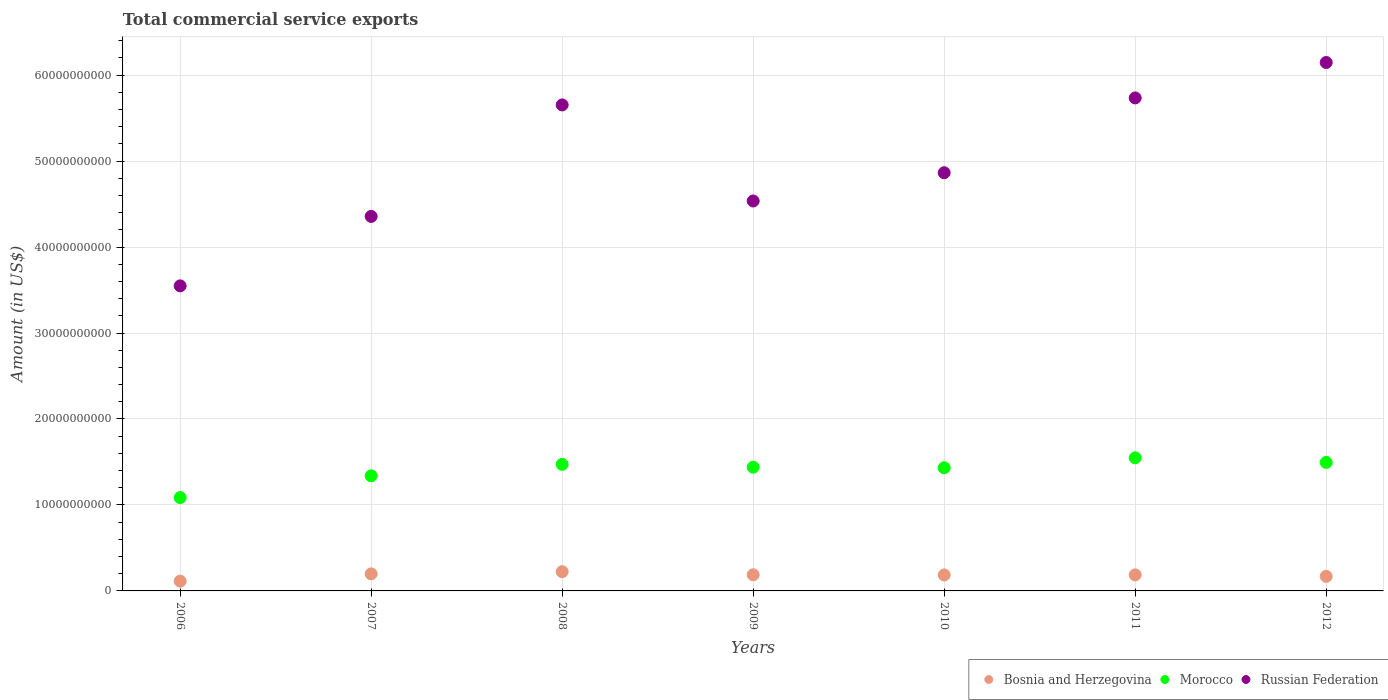How many different coloured dotlines are there?
Offer a very short reply. 3. What is the total commercial service exports in Russian Federation in 2009?
Your response must be concise. 4.54e+1. Across all years, what is the maximum total commercial service exports in Morocco?
Provide a short and direct response. 1.55e+1. Across all years, what is the minimum total commercial service exports in Morocco?
Make the answer very short. 1.09e+1. In which year was the total commercial service exports in Morocco minimum?
Your answer should be very brief. 2006. What is the total total commercial service exports in Morocco in the graph?
Make the answer very short. 9.81e+1. What is the difference between the total commercial service exports in Bosnia and Herzegovina in 2011 and that in 2012?
Make the answer very short. 1.73e+08. What is the difference between the total commercial service exports in Russian Federation in 2010 and the total commercial service exports in Bosnia and Herzegovina in 2009?
Give a very brief answer. 4.68e+1. What is the average total commercial service exports in Bosnia and Herzegovina per year?
Make the answer very short. 1.81e+09. In the year 2009, what is the difference between the total commercial service exports in Morocco and total commercial service exports in Bosnia and Herzegovina?
Ensure brevity in your answer.  1.25e+1. What is the ratio of the total commercial service exports in Russian Federation in 2006 to that in 2007?
Make the answer very short. 0.81. Is the total commercial service exports in Morocco in 2006 less than that in 2009?
Your answer should be very brief. Yes. Is the difference between the total commercial service exports in Morocco in 2006 and 2008 greater than the difference between the total commercial service exports in Bosnia and Herzegovina in 2006 and 2008?
Offer a very short reply. No. What is the difference between the highest and the second highest total commercial service exports in Russian Federation?
Give a very brief answer. 4.12e+09. What is the difference between the highest and the lowest total commercial service exports in Russian Federation?
Offer a terse response. 2.60e+1. In how many years, is the total commercial service exports in Morocco greater than the average total commercial service exports in Morocco taken over all years?
Your answer should be very brief. 5. Does the total commercial service exports in Russian Federation monotonically increase over the years?
Ensure brevity in your answer.  No. Is the total commercial service exports in Morocco strictly greater than the total commercial service exports in Russian Federation over the years?
Keep it short and to the point. No. Is the total commercial service exports in Bosnia and Herzegovina strictly less than the total commercial service exports in Russian Federation over the years?
Make the answer very short. Yes. How many years are there in the graph?
Make the answer very short. 7. What is the difference between two consecutive major ticks on the Y-axis?
Your response must be concise. 1.00e+1. Are the values on the major ticks of Y-axis written in scientific E-notation?
Your answer should be compact. No. Does the graph contain grids?
Your response must be concise. Yes. How are the legend labels stacked?
Your response must be concise. Horizontal. What is the title of the graph?
Your answer should be very brief. Total commercial service exports. What is the label or title of the Y-axis?
Keep it short and to the point. Amount (in US$). What is the Amount (in US$) of Bosnia and Herzegovina in 2006?
Provide a succinct answer. 1.14e+09. What is the Amount (in US$) in Morocco in 2006?
Give a very brief answer. 1.09e+1. What is the Amount (in US$) in Russian Federation in 2006?
Keep it short and to the point. 3.55e+1. What is the Amount (in US$) of Bosnia and Herzegovina in 2007?
Ensure brevity in your answer.  1.99e+09. What is the Amount (in US$) in Morocco in 2007?
Provide a succinct answer. 1.34e+1. What is the Amount (in US$) in Russian Federation in 2007?
Your answer should be compact. 4.36e+1. What is the Amount (in US$) in Bosnia and Herzegovina in 2008?
Provide a succinct answer. 2.24e+09. What is the Amount (in US$) in Morocco in 2008?
Provide a succinct answer. 1.47e+1. What is the Amount (in US$) of Russian Federation in 2008?
Your answer should be compact. 5.65e+1. What is the Amount (in US$) of Bosnia and Herzegovina in 2009?
Provide a succinct answer. 1.88e+09. What is the Amount (in US$) of Morocco in 2009?
Make the answer very short. 1.44e+1. What is the Amount (in US$) in Russian Federation in 2009?
Keep it short and to the point. 4.54e+1. What is the Amount (in US$) in Bosnia and Herzegovina in 2010?
Keep it short and to the point. 1.86e+09. What is the Amount (in US$) of Morocco in 2010?
Give a very brief answer. 1.43e+1. What is the Amount (in US$) of Russian Federation in 2010?
Provide a short and direct response. 4.86e+1. What is the Amount (in US$) in Bosnia and Herzegovina in 2011?
Your answer should be very brief. 1.87e+09. What is the Amount (in US$) in Morocco in 2011?
Make the answer very short. 1.55e+1. What is the Amount (in US$) in Russian Federation in 2011?
Make the answer very short. 5.73e+1. What is the Amount (in US$) in Bosnia and Herzegovina in 2012?
Offer a terse response. 1.69e+09. What is the Amount (in US$) in Morocco in 2012?
Your answer should be very brief. 1.49e+1. What is the Amount (in US$) in Russian Federation in 2012?
Keep it short and to the point. 6.15e+1. Across all years, what is the maximum Amount (in US$) in Bosnia and Herzegovina?
Give a very brief answer. 2.24e+09. Across all years, what is the maximum Amount (in US$) of Morocco?
Your response must be concise. 1.55e+1. Across all years, what is the maximum Amount (in US$) in Russian Federation?
Provide a short and direct response. 6.15e+1. Across all years, what is the minimum Amount (in US$) in Bosnia and Herzegovina?
Ensure brevity in your answer.  1.14e+09. Across all years, what is the minimum Amount (in US$) in Morocco?
Offer a very short reply. 1.09e+1. Across all years, what is the minimum Amount (in US$) in Russian Federation?
Make the answer very short. 3.55e+1. What is the total Amount (in US$) in Bosnia and Herzegovina in the graph?
Offer a very short reply. 1.27e+1. What is the total Amount (in US$) in Morocco in the graph?
Give a very brief answer. 9.81e+1. What is the total Amount (in US$) of Russian Federation in the graph?
Keep it short and to the point. 3.48e+11. What is the difference between the Amount (in US$) in Bosnia and Herzegovina in 2006 and that in 2007?
Make the answer very short. -8.48e+08. What is the difference between the Amount (in US$) of Morocco in 2006 and that in 2007?
Your answer should be compact. -2.53e+09. What is the difference between the Amount (in US$) of Russian Federation in 2006 and that in 2007?
Give a very brief answer. -8.08e+09. What is the difference between the Amount (in US$) of Bosnia and Herzegovina in 2006 and that in 2008?
Provide a succinct answer. -1.10e+09. What is the difference between the Amount (in US$) in Morocco in 2006 and that in 2008?
Provide a succinct answer. -3.87e+09. What is the difference between the Amount (in US$) of Russian Federation in 2006 and that in 2008?
Your answer should be compact. -2.10e+1. What is the difference between the Amount (in US$) of Bosnia and Herzegovina in 2006 and that in 2009?
Offer a terse response. -7.43e+08. What is the difference between the Amount (in US$) of Morocco in 2006 and that in 2009?
Ensure brevity in your answer.  -3.53e+09. What is the difference between the Amount (in US$) of Russian Federation in 2006 and that in 2009?
Provide a short and direct response. -9.87e+09. What is the difference between the Amount (in US$) of Bosnia and Herzegovina in 2006 and that in 2010?
Offer a terse response. -7.23e+08. What is the difference between the Amount (in US$) of Morocco in 2006 and that in 2010?
Your response must be concise. -3.47e+09. What is the difference between the Amount (in US$) in Russian Federation in 2006 and that in 2010?
Provide a short and direct response. -1.32e+1. What is the difference between the Amount (in US$) of Bosnia and Herzegovina in 2006 and that in 2011?
Offer a terse response. -7.30e+08. What is the difference between the Amount (in US$) of Morocco in 2006 and that in 2011?
Provide a succinct answer. -4.63e+09. What is the difference between the Amount (in US$) in Russian Federation in 2006 and that in 2011?
Keep it short and to the point. -2.19e+1. What is the difference between the Amount (in US$) in Bosnia and Herzegovina in 2006 and that in 2012?
Your answer should be compact. -5.57e+08. What is the difference between the Amount (in US$) of Morocco in 2006 and that in 2012?
Offer a very short reply. -4.09e+09. What is the difference between the Amount (in US$) of Russian Federation in 2006 and that in 2012?
Your response must be concise. -2.60e+1. What is the difference between the Amount (in US$) of Bosnia and Herzegovina in 2007 and that in 2008?
Give a very brief answer. -2.53e+08. What is the difference between the Amount (in US$) of Morocco in 2007 and that in 2008?
Your answer should be very brief. -1.34e+09. What is the difference between the Amount (in US$) in Russian Federation in 2007 and that in 2008?
Provide a succinct answer. -1.30e+1. What is the difference between the Amount (in US$) of Bosnia and Herzegovina in 2007 and that in 2009?
Ensure brevity in your answer.  1.05e+08. What is the difference between the Amount (in US$) of Morocco in 2007 and that in 2009?
Provide a short and direct response. -9.99e+08. What is the difference between the Amount (in US$) of Russian Federation in 2007 and that in 2009?
Your answer should be compact. -1.79e+09. What is the difference between the Amount (in US$) in Bosnia and Herzegovina in 2007 and that in 2010?
Offer a terse response. 1.25e+08. What is the difference between the Amount (in US$) of Morocco in 2007 and that in 2010?
Give a very brief answer. -9.39e+08. What is the difference between the Amount (in US$) of Russian Federation in 2007 and that in 2010?
Provide a short and direct response. -5.08e+09. What is the difference between the Amount (in US$) in Bosnia and Herzegovina in 2007 and that in 2011?
Your answer should be compact. 1.18e+08. What is the difference between the Amount (in US$) of Morocco in 2007 and that in 2011?
Provide a succinct answer. -2.10e+09. What is the difference between the Amount (in US$) of Russian Federation in 2007 and that in 2011?
Offer a very short reply. -1.38e+1. What is the difference between the Amount (in US$) of Bosnia and Herzegovina in 2007 and that in 2012?
Your answer should be very brief. 2.91e+08. What is the difference between the Amount (in US$) of Morocco in 2007 and that in 2012?
Your response must be concise. -1.56e+09. What is the difference between the Amount (in US$) of Russian Federation in 2007 and that in 2012?
Your response must be concise. -1.79e+1. What is the difference between the Amount (in US$) in Bosnia and Herzegovina in 2008 and that in 2009?
Offer a very short reply. 3.57e+08. What is the difference between the Amount (in US$) of Morocco in 2008 and that in 2009?
Your answer should be compact. 3.37e+08. What is the difference between the Amount (in US$) in Russian Federation in 2008 and that in 2009?
Offer a very short reply. 1.12e+1. What is the difference between the Amount (in US$) of Bosnia and Herzegovina in 2008 and that in 2010?
Offer a terse response. 3.77e+08. What is the difference between the Amount (in US$) in Morocco in 2008 and that in 2010?
Offer a terse response. 3.96e+08. What is the difference between the Amount (in US$) of Russian Federation in 2008 and that in 2010?
Your answer should be compact. 7.89e+09. What is the difference between the Amount (in US$) of Bosnia and Herzegovina in 2008 and that in 2011?
Keep it short and to the point. 3.70e+08. What is the difference between the Amount (in US$) of Morocco in 2008 and that in 2011?
Keep it short and to the point. -7.61e+08. What is the difference between the Amount (in US$) in Russian Federation in 2008 and that in 2011?
Your answer should be very brief. -8.14e+08. What is the difference between the Amount (in US$) of Bosnia and Herzegovina in 2008 and that in 2012?
Offer a terse response. 5.44e+08. What is the difference between the Amount (in US$) of Morocco in 2008 and that in 2012?
Provide a short and direct response. -2.22e+08. What is the difference between the Amount (in US$) of Russian Federation in 2008 and that in 2012?
Offer a terse response. -4.93e+09. What is the difference between the Amount (in US$) in Bosnia and Herzegovina in 2009 and that in 2010?
Keep it short and to the point. 2.00e+07. What is the difference between the Amount (in US$) of Morocco in 2009 and that in 2010?
Your answer should be compact. 5.92e+07. What is the difference between the Amount (in US$) of Russian Federation in 2009 and that in 2010?
Your answer should be very brief. -3.29e+09. What is the difference between the Amount (in US$) of Bosnia and Herzegovina in 2009 and that in 2011?
Provide a succinct answer. 1.30e+07. What is the difference between the Amount (in US$) in Morocco in 2009 and that in 2011?
Provide a succinct answer. -1.10e+09. What is the difference between the Amount (in US$) of Russian Federation in 2009 and that in 2011?
Offer a very short reply. -1.20e+1. What is the difference between the Amount (in US$) in Bosnia and Herzegovina in 2009 and that in 2012?
Offer a terse response. 1.86e+08. What is the difference between the Amount (in US$) in Morocco in 2009 and that in 2012?
Offer a terse response. -5.58e+08. What is the difference between the Amount (in US$) in Russian Federation in 2009 and that in 2012?
Your response must be concise. -1.61e+1. What is the difference between the Amount (in US$) of Bosnia and Herzegovina in 2010 and that in 2011?
Your answer should be very brief. -7.01e+06. What is the difference between the Amount (in US$) of Morocco in 2010 and that in 2011?
Offer a terse response. -1.16e+09. What is the difference between the Amount (in US$) of Russian Federation in 2010 and that in 2011?
Your response must be concise. -8.70e+09. What is the difference between the Amount (in US$) in Bosnia and Herzegovina in 2010 and that in 2012?
Provide a short and direct response. 1.66e+08. What is the difference between the Amount (in US$) of Morocco in 2010 and that in 2012?
Your response must be concise. -6.18e+08. What is the difference between the Amount (in US$) in Russian Federation in 2010 and that in 2012?
Give a very brief answer. -1.28e+1. What is the difference between the Amount (in US$) in Bosnia and Herzegovina in 2011 and that in 2012?
Provide a short and direct response. 1.73e+08. What is the difference between the Amount (in US$) of Morocco in 2011 and that in 2012?
Provide a succinct answer. 5.40e+08. What is the difference between the Amount (in US$) in Russian Federation in 2011 and that in 2012?
Make the answer very short. -4.12e+09. What is the difference between the Amount (in US$) of Bosnia and Herzegovina in 2006 and the Amount (in US$) of Morocco in 2007?
Provide a short and direct response. -1.23e+1. What is the difference between the Amount (in US$) of Bosnia and Herzegovina in 2006 and the Amount (in US$) of Russian Federation in 2007?
Provide a short and direct response. -4.24e+1. What is the difference between the Amount (in US$) of Morocco in 2006 and the Amount (in US$) of Russian Federation in 2007?
Give a very brief answer. -3.27e+1. What is the difference between the Amount (in US$) in Bosnia and Herzegovina in 2006 and the Amount (in US$) in Morocco in 2008?
Your answer should be very brief. -1.36e+1. What is the difference between the Amount (in US$) of Bosnia and Herzegovina in 2006 and the Amount (in US$) of Russian Federation in 2008?
Provide a succinct answer. -5.54e+1. What is the difference between the Amount (in US$) in Morocco in 2006 and the Amount (in US$) in Russian Federation in 2008?
Your answer should be very brief. -4.57e+1. What is the difference between the Amount (in US$) of Bosnia and Herzegovina in 2006 and the Amount (in US$) of Morocco in 2009?
Offer a terse response. -1.33e+1. What is the difference between the Amount (in US$) in Bosnia and Herzegovina in 2006 and the Amount (in US$) in Russian Federation in 2009?
Keep it short and to the point. -4.42e+1. What is the difference between the Amount (in US$) of Morocco in 2006 and the Amount (in US$) of Russian Federation in 2009?
Keep it short and to the point. -3.45e+1. What is the difference between the Amount (in US$) in Bosnia and Herzegovina in 2006 and the Amount (in US$) in Morocco in 2010?
Provide a succinct answer. -1.32e+1. What is the difference between the Amount (in US$) of Bosnia and Herzegovina in 2006 and the Amount (in US$) of Russian Federation in 2010?
Give a very brief answer. -4.75e+1. What is the difference between the Amount (in US$) of Morocco in 2006 and the Amount (in US$) of Russian Federation in 2010?
Provide a short and direct response. -3.78e+1. What is the difference between the Amount (in US$) of Bosnia and Herzegovina in 2006 and the Amount (in US$) of Morocco in 2011?
Your response must be concise. -1.43e+1. What is the difference between the Amount (in US$) in Bosnia and Herzegovina in 2006 and the Amount (in US$) in Russian Federation in 2011?
Your answer should be compact. -5.62e+1. What is the difference between the Amount (in US$) in Morocco in 2006 and the Amount (in US$) in Russian Federation in 2011?
Give a very brief answer. -4.65e+1. What is the difference between the Amount (in US$) of Bosnia and Herzegovina in 2006 and the Amount (in US$) of Morocco in 2012?
Your answer should be very brief. -1.38e+1. What is the difference between the Amount (in US$) in Bosnia and Herzegovina in 2006 and the Amount (in US$) in Russian Federation in 2012?
Your answer should be very brief. -6.03e+1. What is the difference between the Amount (in US$) in Morocco in 2006 and the Amount (in US$) in Russian Federation in 2012?
Your answer should be very brief. -5.06e+1. What is the difference between the Amount (in US$) in Bosnia and Herzegovina in 2007 and the Amount (in US$) in Morocco in 2008?
Make the answer very short. -1.27e+1. What is the difference between the Amount (in US$) of Bosnia and Herzegovina in 2007 and the Amount (in US$) of Russian Federation in 2008?
Keep it short and to the point. -5.45e+1. What is the difference between the Amount (in US$) of Morocco in 2007 and the Amount (in US$) of Russian Federation in 2008?
Offer a very short reply. -4.31e+1. What is the difference between the Amount (in US$) in Bosnia and Herzegovina in 2007 and the Amount (in US$) in Morocco in 2009?
Your answer should be very brief. -1.24e+1. What is the difference between the Amount (in US$) of Bosnia and Herzegovina in 2007 and the Amount (in US$) of Russian Federation in 2009?
Your answer should be compact. -4.34e+1. What is the difference between the Amount (in US$) of Morocco in 2007 and the Amount (in US$) of Russian Federation in 2009?
Provide a succinct answer. -3.20e+1. What is the difference between the Amount (in US$) of Bosnia and Herzegovina in 2007 and the Amount (in US$) of Morocco in 2010?
Your answer should be very brief. -1.23e+1. What is the difference between the Amount (in US$) of Bosnia and Herzegovina in 2007 and the Amount (in US$) of Russian Federation in 2010?
Give a very brief answer. -4.67e+1. What is the difference between the Amount (in US$) of Morocco in 2007 and the Amount (in US$) of Russian Federation in 2010?
Keep it short and to the point. -3.53e+1. What is the difference between the Amount (in US$) of Bosnia and Herzegovina in 2007 and the Amount (in US$) of Morocco in 2011?
Ensure brevity in your answer.  -1.35e+1. What is the difference between the Amount (in US$) of Bosnia and Herzegovina in 2007 and the Amount (in US$) of Russian Federation in 2011?
Your response must be concise. -5.54e+1. What is the difference between the Amount (in US$) of Morocco in 2007 and the Amount (in US$) of Russian Federation in 2011?
Provide a short and direct response. -4.40e+1. What is the difference between the Amount (in US$) of Bosnia and Herzegovina in 2007 and the Amount (in US$) of Morocco in 2012?
Provide a short and direct response. -1.30e+1. What is the difference between the Amount (in US$) in Bosnia and Herzegovina in 2007 and the Amount (in US$) in Russian Federation in 2012?
Keep it short and to the point. -5.95e+1. What is the difference between the Amount (in US$) in Morocco in 2007 and the Amount (in US$) in Russian Federation in 2012?
Ensure brevity in your answer.  -4.81e+1. What is the difference between the Amount (in US$) of Bosnia and Herzegovina in 2008 and the Amount (in US$) of Morocco in 2009?
Offer a very short reply. -1.22e+1. What is the difference between the Amount (in US$) of Bosnia and Herzegovina in 2008 and the Amount (in US$) of Russian Federation in 2009?
Offer a terse response. -4.31e+1. What is the difference between the Amount (in US$) of Morocco in 2008 and the Amount (in US$) of Russian Federation in 2009?
Your answer should be very brief. -3.06e+1. What is the difference between the Amount (in US$) in Bosnia and Herzegovina in 2008 and the Amount (in US$) in Morocco in 2010?
Give a very brief answer. -1.21e+1. What is the difference between the Amount (in US$) in Bosnia and Herzegovina in 2008 and the Amount (in US$) in Russian Federation in 2010?
Keep it short and to the point. -4.64e+1. What is the difference between the Amount (in US$) of Morocco in 2008 and the Amount (in US$) of Russian Federation in 2010?
Provide a short and direct response. -3.39e+1. What is the difference between the Amount (in US$) of Bosnia and Herzegovina in 2008 and the Amount (in US$) of Morocco in 2011?
Ensure brevity in your answer.  -1.32e+1. What is the difference between the Amount (in US$) of Bosnia and Herzegovina in 2008 and the Amount (in US$) of Russian Federation in 2011?
Your response must be concise. -5.51e+1. What is the difference between the Amount (in US$) in Morocco in 2008 and the Amount (in US$) in Russian Federation in 2011?
Ensure brevity in your answer.  -4.26e+1. What is the difference between the Amount (in US$) in Bosnia and Herzegovina in 2008 and the Amount (in US$) in Morocco in 2012?
Ensure brevity in your answer.  -1.27e+1. What is the difference between the Amount (in US$) of Bosnia and Herzegovina in 2008 and the Amount (in US$) of Russian Federation in 2012?
Your answer should be very brief. -5.92e+1. What is the difference between the Amount (in US$) of Morocco in 2008 and the Amount (in US$) of Russian Federation in 2012?
Your response must be concise. -4.67e+1. What is the difference between the Amount (in US$) in Bosnia and Herzegovina in 2009 and the Amount (in US$) in Morocco in 2010?
Your answer should be very brief. -1.24e+1. What is the difference between the Amount (in US$) in Bosnia and Herzegovina in 2009 and the Amount (in US$) in Russian Federation in 2010?
Make the answer very short. -4.68e+1. What is the difference between the Amount (in US$) in Morocco in 2009 and the Amount (in US$) in Russian Federation in 2010?
Make the answer very short. -3.43e+1. What is the difference between the Amount (in US$) in Bosnia and Herzegovina in 2009 and the Amount (in US$) in Morocco in 2011?
Offer a terse response. -1.36e+1. What is the difference between the Amount (in US$) in Bosnia and Herzegovina in 2009 and the Amount (in US$) in Russian Federation in 2011?
Your response must be concise. -5.55e+1. What is the difference between the Amount (in US$) in Morocco in 2009 and the Amount (in US$) in Russian Federation in 2011?
Your response must be concise. -4.30e+1. What is the difference between the Amount (in US$) in Bosnia and Herzegovina in 2009 and the Amount (in US$) in Morocco in 2012?
Provide a succinct answer. -1.31e+1. What is the difference between the Amount (in US$) of Bosnia and Herzegovina in 2009 and the Amount (in US$) of Russian Federation in 2012?
Ensure brevity in your answer.  -5.96e+1. What is the difference between the Amount (in US$) of Morocco in 2009 and the Amount (in US$) of Russian Federation in 2012?
Your response must be concise. -4.71e+1. What is the difference between the Amount (in US$) in Bosnia and Herzegovina in 2010 and the Amount (in US$) in Morocco in 2011?
Offer a terse response. -1.36e+1. What is the difference between the Amount (in US$) of Bosnia and Herzegovina in 2010 and the Amount (in US$) of Russian Federation in 2011?
Keep it short and to the point. -5.55e+1. What is the difference between the Amount (in US$) of Morocco in 2010 and the Amount (in US$) of Russian Federation in 2011?
Give a very brief answer. -4.30e+1. What is the difference between the Amount (in US$) of Bosnia and Herzegovina in 2010 and the Amount (in US$) of Morocco in 2012?
Make the answer very short. -1.31e+1. What is the difference between the Amount (in US$) in Bosnia and Herzegovina in 2010 and the Amount (in US$) in Russian Federation in 2012?
Offer a terse response. -5.96e+1. What is the difference between the Amount (in US$) in Morocco in 2010 and the Amount (in US$) in Russian Federation in 2012?
Ensure brevity in your answer.  -4.71e+1. What is the difference between the Amount (in US$) of Bosnia and Herzegovina in 2011 and the Amount (in US$) of Morocco in 2012?
Keep it short and to the point. -1.31e+1. What is the difference between the Amount (in US$) in Bosnia and Herzegovina in 2011 and the Amount (in US$) in Russian Federation in 2012?
Your answer should be very brief. -5.96e+1. What is the difference between the Amount (in US$) of Morocco in 2011 and the Amount (in US$) of Russian Federation in 2012?
Provide a succinct answer. -4.60e+1. What is the average Amount (in US$) in Bosnia and Herzegovina per year?
Offer a terse response. 1.81e+09. What is the average Amount (in US$) of Morocco per year?
Your response must be concise. 1.40e+1. What is the average Amount (in US$) in Russian Federation per year?
Keep it short and to the point. 4.98e+1. In the year 2006, what is the difference between the Amount (in US$) of Bosnia and Herzegovina and Amount (in US$) of Morocco?
Give a very brief answer. -9.72e+09. In the year 2006, what is the difference between the Amount (in US$) of Bosnia and Herzegovina and Amount (in US$) of Russian Federation?
Ensure brevity in your answer.  -3.43e+1. In the year 2006, what is the difference between the Amount (in US$) of Morocco and Amount (in US$) of Russian Federation?
Offer a terse response. -2.46e+1. In the year 2007, what is the difference between the Amount (in US$) in Bosnia and Herzegovina and Amount (in US$) in Morocco?
Provide a short and direct response. -1.14e+1. In the year 2007, what is the difference between the Amount (in US$) of Bosnia and Herzegovina and Amount (in US$) of Russian Federation?
Your answer should be very brief. -4.16e+1. In the year 2007, what is the difference between the Amount (in US$) of Morocco and Amount (in US$) of Russian Federation?
Provide a succinct answer. -3.02e+1. In the year 2008, what is the difference between the Amount (in US$) in Bosnia and Herzegovina and Amount (in US$) in Morocco?
Make the answer very short. -1.25e+1. In the year 2008, what is the difference between the Amount (in US$) of Bosnia and Herzegovina and Amount (in US$) of Russian Federation?
Ensure brevity in your answer.  -5.43e+1. In the year 2008, what is the difference between the Amount (in US$) in Morocco and Amount (in US$) in Russian Federation?
Keep it short and to the point. -4.18e+1. In the year 2009, what is the difference between the Amount (in US$) of Bosnia and Herzegovina and Amount (in US$) of Morocco?
Offer a very short reply. -1.25e+1. In the year 2009, what is the difference between the Amount (in US$) of Bosnia and Herzegovina and Amount (in US$) of Russian Federation?
Give a very brief answer. -4.35e+1. In the year 2009, what is the difference between the Amount (in US$) in Morocco and Amount (in US$) in Russian Federation?
Make the answer very short. -3.10e+1. In the year 2010, what is the difference between the Amount (in US$) of Bosnia and Herzegovina and Amount (in US$) of Morocco?
Your response must be concise. -1.25e+1. In the year 2010, what is the difference between the Amount (in US$) in Bosnia and Herzegovina and Amount (in US$) in Russian Federation?
Your answer should be compact. -4.68e+1. In the year 2010, what is the difference between the Amount (in US$) in Morocco and Amount (in US$) in Russian Federation?
Offer a very short reply. -3.43e+1. In the year 2011, what is the difference between the Amount (in US$) in Bosnia and Herzegovina and Amount (in US$) in Morocco?
Make the answer very short. -1.36e+1. In the year 2011, what is the difference between the Amount (in US$) of Bosnia and Herzegovina and Amount (in US$) of Russian Federation?
Keep it short and to the point. -5.55e+1. In the year 2011, what is the difference between the Amount (in US$) in Morocco and Amount (in US$) in Russian Federation?
Keep it short and to the point. -4.19e+1. In the year 2012, what is the difference between the Amount (in US$) of Bosnia and Herzegovina and Amount (in US$) of Morocco?
Keep it short and to the point. -1.33e+1. In the year 2012, what is the difference between the Amount (in US$) of Bosnia and Herzegovina and Amount (in US$) of Russian Federation?
Your response must be concise. -5.98e+1. In the year 2012, what is the difference between the Amount (in US$) of Morocco and Amount (in US$) of Russian Federation?
Keep it short and to the point. -4.65e+1. What is the ratio of the Amount (in US$) in Bosnia and Herzegovina in 2006 to that in 2007?
Make the answer very short. 0.57. What is the ratio of the Amount (in US$) in Morocco in 2006 to that in 2007?
Your response must be concise. 0.81. What is the ratio of the Amount (in US$) in Russian Federation in 2006 to that in 2007?
Offer a terse response. 0.81. What is the ratio of the Amount (in US$) in Bosnia and Herzegovina in 2006 to that in 2008?
Ensure brevity in your answer.  0.51. What is the ratio of the Amount (in US$) in Morocco in 2006 to that in 2008?
Make the answer very short. 0.74. What is the ratio of the Amount (in US$) of Russian Federation in 2006 to that in 2008?
Make the answer very short. 0.63. What is the ratio of the Amount (in US$) in Bosnia and Herzegovina in 2006 to that in 2009?
Keep it short and to the point. 0.6. What is the ratio of the Amount (in US$) of Morocco in 2006 to that in 2009?
Your answer should be very brief. 0.75. What is the ratio of the Amount (in US$) in Russian Federation in 2006 to that in 2009?
Your answer should be compact. 0.78. What is the ratio of the Amount (in US$) of Bosnia and Herzegovina in 2006 to that in 2010?
Your answer should be very brief. 0.61. What is the ratio of the Amount (in US$) of Morocco in 2006 to that in 2010?
Give a very brief answer. 0.76. What is the ratio of the Amount (in US$) in Russian Federation in 2006 to that in 2010?
Make the answer very short. 0.73. What is the ratio of the Amount (in US$) in Bosnia and Herzegovina in 2006 to that in 2011?
Your answer should be very brief. 0.61. What is the ratio of the Amount (in US$) in Morocco in 2006 to that in 2011?
Offer a very short reply. 0.7. What is the ratio of the Amount (in US$) in Russian Federation in 2006 to that in 2011?
Offer a terse response. 0.62. What is the ratio of the Amount (in US$) of Bosnia and Herzegovina in 2006 to that in 2012?
Make the answer very short. 0.67. What is the ratio of the Amount (in US$) of Morocco in 2006 to that in 2012?
Provide a short and direct response. 0.73. What is the ratio of the Amount (in US$) of Russian Federation in 2006 to that in 2012?
Make the answer very short. 0.58. What is the ratio of the Amount (in US$) in Bosnia and Herzegovina in 2007 to that in 2008?
Offer a terse response. 0.89. What is the ratio of the Amount (in US$) in Morocco in 2007 to that in 2008?
Provide a short and direct response. 0.91. What is the ratio of the Amount (in US$) in Russian Federation in 2007 to that in 2008?
Keep it short and to the point. 0.77. What is the ratio of the Amount (in US$) in Bosnia and Herzegovina in 2007 to that in 2009?
Your answer should be very brief. 1.06. What is the ratio of the Amount (in US$) in Morocco in 2007 to that in 2009?
Offer a very short reply. 0.93. What is the ratio of the Amount (in US$) in Russian Federation in 2007 to that in 2009?
Give a very brief answer. 0.96. What is the ratio of the Amount (in US$) of Bosnia and Herzegovina in 2007 to that in 2010?
Keep it short and to the point. 1.07. What is the ratio of the Amount (in US$) in Morocco in 2007 to that in 2010?
Give a very brief answer. 0.93. What is the ratio of the Amount (in US$) in Russian Federation in 2007 to that in 2010?
Give a very brief answer. 0.9. What is the ratio of the Amount (in US$) in Bosnia and Herzegovina in 2007 to that in 2011?
Offer a very short reply. 1.06. What is the ratio of the Amount (in US$) of Morocco in 2007 to that in 2011?
Keep it short and to the point. 0.86. What is the ratio of the Amount (in US$) of Russian Federation in 2007 to that in 2011?
Make the answer very short. 0.76. What is the ratio of the Amount (in US$) in Bosnia and Herzegovina in 2007 to that in 2012?
Offer a very short reply. 1.17. What is the ratio of the Amount (in US$) in Morocco in 2007 to that in 2012?
Keep it short and to the point. 0.9. What is the ratio of the Amount (in US$) in Russian Federation in 2007 to that in 2012?
Offer a very short reply. 0.71. What is the ratio of the Amount (in US$) in Bosnia and Herzegovina in 2008 to that in 2009?
Your response must be concise. 1.19. What is the ratio of the Amount (in US$) of Morocco in 2008 to that in 2009?
Your answer should be compact. 1.02. What is the ratio of the Amount (in US$) in Russian Federation in 2008 to that in 2009?
Ensure brevity in your answer.  1.25. What is the ratio of the Amount (in US$) of Bosnia and Herzegovina in 2008 to that in 2010?
Your response must be concise. 1.2. What is the ratio of the Amount (in US$) in Morocco in 2008 to that in 2010?
Keep it short and to the point. 1.03. What is the ratio of the Amount (in US$) of Russian Federation in 2008 to that in 2010?
Keep it short and to the point. 1.16. What is the ratio of the Amount (in US$) in Bosnia and Herzegovina in 2008 to that in 2011?
Offer a terse response. 1.2. What is the ratio of the Amount (in US$) in Morocco in 2008 to that in 2011?
Provide a succinct answer. 0.95. What is the ratio of the Amount (in US$) of Russian Federation in 2008 to that in 2011?
Provide a short and direct response. 0.99. What is the ratio of the Amount (in US$) in Bosnia and Herzegovina in 2008 to that in 2012?
Your answer should be compact. 1.32. What is the ratio of the Amount (in US$) of Morocco in 2008 to that in 2012?
Offer a very short reply. 0.99. What is the ratio of the Amount (in US$) in Russian Federation in 2008 to that in 2012?
Ensure brevity in your answer.  0.92. What is the ratio of the Amount (in US$) in Bosnia and Herzegovina in 2009 to that in 2010?
Ensure brevity in your answer.  1.01. What is the ratio of the Amount (in US$) of Morocco in 2009 to that in 2010?
Your answer should be compact. 1. What is the ratio of the Amount (in US$) of Russian Federation in 2009 to that in 2010?
Provide a short and direct response. 0.93. What is the ratio of the Amount (in US$) of Bosnia and Herzegovina in 2009 to that in 2011?
Keep it short and to the point. 1.01. What is the ratio of the Amount (in US$) in Morocco in 2009 to that in 2011?
Give a very brief answer. 0.93. What is the ratio of the Amount (in US$) in Russian Federation in 2009 to that in 2011?
Your answer should be compact. 0.79. What is the ratio of the Amount (in US$) of Bosnia and Herzegovina in 2009 to that in 2012?
Your answer should be very brief. 1.11. What is the ratio of the Amount (in US$) of Morocco in 2009 to that in 2012?
Provide a short and direct response. 0.96. What is the ratio of the Amount (in US$) in Russian Federation in 2009 to that in 2012?
Keep it short and to the point. 0.74. What is the ratio of the Amount (in US$) of Morocco in 2010 to that in 2011?
Your response must be concise. 0.93. What is the ratio of the Amount (in US$) in Russian Federation in 2010 to that in 2011?
Ensure brevity in your answer.  0.85. What is the ratio of the Amount (in US$) in Bosnia and Herzegovina in 2010 to that in 2012?
Make the answer very short. 1.1. What is the ratio of the Amount (in US$) in Morocco in 2010 to that in 2012?
Offer a terse response. 0.96. What is the ratio of the Amount (in US$) in Russian Federation in 2010 to that in 2012?
Offer a terse response. 0.79. What is the ratio of the Amount (in US$) of Bosnia and Herzegovina in 2011 to that in 2012?
Offer a terse response. 1.1. What is the ratio of the Amount (in US$) of Morocco in 2011 to that in 2012?
Make the answer very short. 1.04. What is the ratio of the Amount (in US$) in Russian Federation in 2011 to that in 2012?
Your answer should be very brief. 0.93. What is the difference between the highest and the second highest Amount (in US$) in Bosnia and Herzegovina?
Offer a very short reply. 2.53e+08. What is the difference between the highest and the second highest Amount (in US$) of Morocco?
Keep it short and to the point. 5.40e+08. What is the difference between the highest and the second highest Amount (in US$) of Russian Federation?
Offer a very short reply. 4.12e+09. What is the difference between the highest and the lowest Amount (in US$) of Bosnia and Herzegovina?
Your answer should be very brief. 1.10e+09. What is the difference between the highest and the lowest Amount (in US$) of Morocco?
Offer a very short reply. 4.63e+09. What is the difference between the highest and the lowest Amount (in US$) of Russian Federation?
Your answer should be very brief. 2.60e+1. 